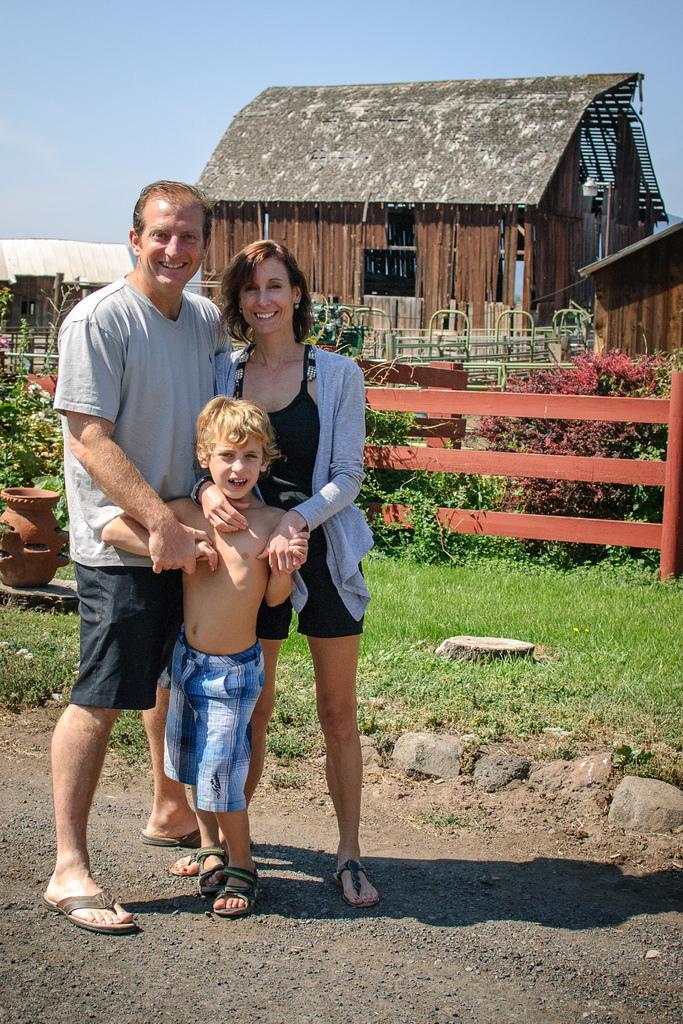Please provide a concise description of this image. In this image in the left a man , a woman and a boy is standing. In the background there is wooden fence, plants, pots, building. The sky is clear. 